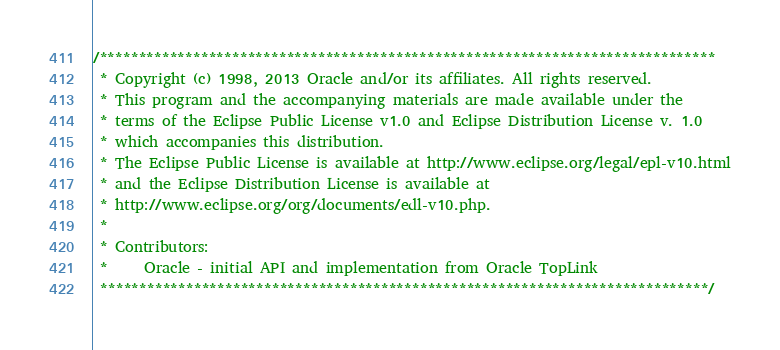Convert code to text. <code><loc_0><loc_0><loc_500><loc_500><_Java_>/*******************************************************************************
 * Copyright (c) 1998, 2013 Oracle and/or its affiliates. All rights reserved.
 * This program and the accompanying materials are made available under the 
 * terms of the Eclipse Public License v1.0 and Eclipse Distribution License v. 1.0 
 * which accompanies this distribution. 
 * The Eclipse Public License is available at http://www.eclipse.org/legal/epl-v10.html
 * and the Eclipse Distribution License is available at 
 * http://www.eclipse.org/org/documents/edl-v10.php.
 *
 * Contributors:
 *     Oracle - initial API and implementation from Oracle TopLink
 ******************************************************************************/  </code> 